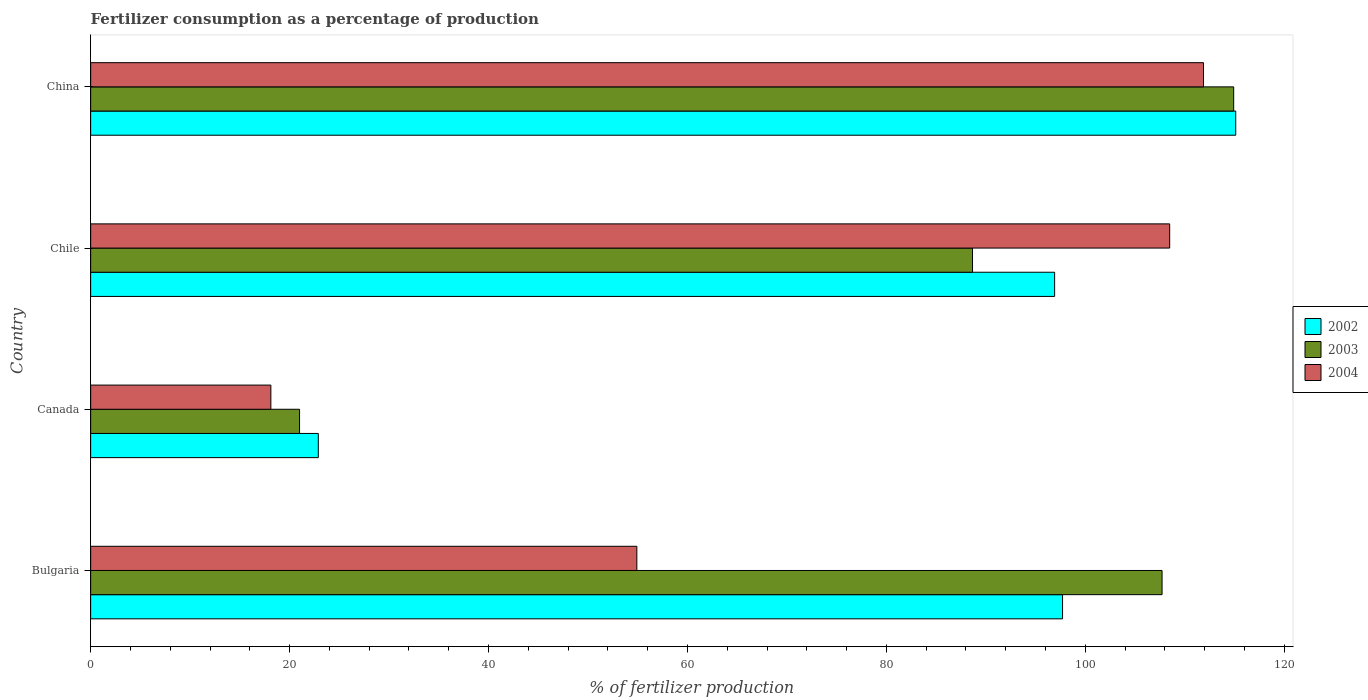How many different coloured bars are there?
Keep it short and to the point. 3. How many groups of bars are there?
Your answer should be compact. 4. Are the number of bars on each tick of the Y-axis equal?
Provide a succinct answer. Yes. How many bars are there on the 2nd tick from the top?
Keep it short and to the point. 3. How many bars are there on the 4th tick from the bottom?
Provide a short and direct response. 3. What is the percentage of fertilizers consumed in 2002 in Canada?
Keep it short and to the point. 22.89. Across all countries, what is the maximum percentage of fertilizers consumed in 2003?
Provide a short and direct response. 114.92. Across all countries, what is the minimum percentage of fertilizers consumed in 2003?
Offer a very short reply. 21. In which country was the percentage of fertilizers consumed in 2004 maximum?
Provide a succinct answer. China. What is the total percentage of fertilizers consumed in 2002 in the graph?
Give a very brief answer. 332.63. What is the difference between the percentage of fertilizers consumed in 2004 in Canada and that in China?
Make the answer very short. -93.77. What is the difference between the percentage of fertilizers consumed in 2003 in China and the percentage of fertilizers consumed in 2004 in Bulgaria?
Your answer should be very brief. 60. What is the average percentage of fertilizers consumed in 2003 per country?
Provide a succinct answer. 83.07. What is the difference between the percentage of fertilizers consumed in 2002 and percentage of fertilizers consumed in 2003 in Canada?
Make the answer very short. 1.88. In how many countries, is the percentage of fertilizers consumed in 2003 greater than 68 %?
Provide a short and direct response. 3. What is the ratio of the percentage of fertilizers consumed in 2002 in Bulgaria to that in Canada?
Provide a succinct answer. 4.27. Is the percentage of fertilizers consumed in 2002 in Canada less than that in China?
Give a very brief answer. Yes. Is the difference between the percentage of fertilizers consumed in 2002 in Bulgaria and Chile greater than the difference between the percentage of fertilizers consumed in 2003 in Bulgaria and Chile?
Make the answer very short. No. What is the difference between the highest and the second highest percentage of fertilizers consumed in 2003?
Your response must be concise. 7.2. What is the difference between the highest and the lowest percentage of fertilizers consumed in 2003?
Offer a terse response. 93.91. Is the sum of the percentage of fertilizers consumed in 2004 in Bulgaria and Canada greater than the maximum percentage of fertilizers consumed in 2003 across all countries?
Your answer should be very brief. No. Is it the case that in every country, the sum of the percentage of fertilizers consumed in 2003 and percentage of fertilizers consumed in 2002 is greater than the percentage of fertilizers consumed in 2004?
Provide a short and direct response. Yes. How many bars are there?
Offer a terse response. 12. How many countries are there in the graph?
Your answer should be very brief. 4. Are the values on the major ticks of X-axis written in scientific E-notation?
Offer a terse response. No. Does the graph contain any zero values?
Keep it short and to the point. No. Does the graph contain grids?
Your response must be concise. No. Where does the legend appear in the graph?
Keep it short and to the point. Center right. How many legend labels are there?
Offer a terse response. 3. What is the title of the graph?
Make the answer very short. Fertilizer consumption as a percentage of production. What is the label or title of the X-axis?
Keep it short and to the point. % of fertilizer production. What is the % of fertilizer production in 2002 in Bulgaria?
Keep it short and to the point. 97.71. What is the % of fertilizer production of 2003 in Bulgaria?
Provide a succinct answer. 107.72. What is the % of fertilizer production in 2004 in Bulgaria?
Your answer should be very brief. 54.91. What is the % of fertilizer production of 2002 in Canada?
Your answer should be compact. 22.89. What is the % of fertilizer production of 2003 in Canada?
Provide a succinct answer. 21. What is the % of fertilizer production in 2004 in Canada?
Your response must be concise. 18.12. What is the % of fertilizer production of 2002 in Chile?
Offer a terse response. 96.91. What is the % of fertilizer production of 2003 in Chile?
Keep it short and to the point. 88.66. What is the % of fertilizer production of 2004 in Chile?
Provide a short and direct response. 108.48. What is the % of fertilizer production in 2002 in China?
Your answer should be compact. 115.12. What is the % of fertilizer production of 2003 in China?
Offer a very short reply. 114.92. What is the % of fertilizer production in 2004 in China?
Your response must be concise. 111.88. Across all countries, what is the maximum % of fertilizer production in 2002?
Provide a succinct answer. 115.12. Across all countries, what is the maximum % of fertilizer production of 2003?
Your answer should be very brief. 114.92. Across all countries, what is the maximum % of fertilizer production of 2004?
Your answer should be compact. 111.88. Across all countries, what is the minimum % of fertilizer production in 2002?
Provide a short and direct response. 22.89. Across all countries, what is the minimum % of fertilizer production in 2003?
Ensure brevity in your answer.  21. Across all countries, what is the minimum % of fertilizer production of 2004?
Make the answer very short. 18.12. What is the total % of fertilizer production in 2002 in the graph?
Make the answer very short. 332.63. What is the total % of fertilizer production in 2003 in the graph?
Your response must be concise. 332.29. What is the total % of fertilizer production in 2004 in the graph?
Keep it short and to the point. 293.39. What is the difference between the % of fertilizer production of 2002 in Bulgaria and that in Canada?
Offer a very short reply. 74.82. What is the difference between the % of fertilizer production in 2003 in Bulgaria and that in Canada?
Offer a terse response. 86.71. What is the difference between the % of fertilizer production in 2004 in Bulgaria and that in Canada?
Provide a succinct answer. 36.8. What is the difference between the % of fertilizer production of 2002 in Bulgaria and that in Chile?
Provide a succinct answer. 0.8. What is the difference between the % of fertilizer production of 2003 in Bulgaria and that in Chile?
Offer a terse response. 19.06. What is the difference between the % of fertilizer production in 2004 in Bulgaria and that in Chile?
Your answer should be compact. -53.57. What is the difference between the % of fertilizer production of 2002 in Bulgaria and that in China?
Your answer should be very brief. -17.41. What is the difference between the % of fertilizer production in 2003 in Bulgaria and that in China?
Your response must be concise. -7.2. What is the difference between the % of fertilizer production in 2004 in Bulgaria and that in China?
Your answer should be very brief. -56.97. What is the difference between the % of fertilizer production in 2002 in Canada and that in Chile?
Your answer should be compact. -74.03. What is the difference between the % of fertilizer production of 2003 in Canada and that in Chile?
Offer a very short reply. -67.66. What is the difference between the % of fertilizer production of 2004 in Canada and that in Chile?
Your response must be concise. -90.37. What is the difference between the % of fertilizer production in 2002 in Canada and that in China?
Your answer should be compact. -92.24. What is the difference between the % of fertilizer production of 2003 in Canada and that in China?
Keep it short and to the point. -93.91. What is the difference between the % of fertilizer production in 2004 in Canada and that in China?
Give a very brief answer. -93.77. What is the difference between the % of fertilizer production of 2002 in Chile and that in China?
Offer a terse response. -18.21. What is the difference between the % of fertilizer production of 2003 in Chile and that in China?
Offer a terse response. -26.26. What is the difference between the % of fertilizer production in 2004 in Chile and that in China?
Your answer should be compact. -3.4. What is the difference between the % of fertilizer production of 2002 in Bulgaria and the % of fertilizer production of 2003 in Canada?
Offer a very short reply. 76.71. What is the difference between the % of fertilizer production of 2002 in Bulgaria and the % of fertilizer production of 2004 in Canada?
Keep it short and to the point. 79.59. What is the difference between the % of fertilizer production of 2003 in Bulgaria and the % of fertilizer production of 2004 in Canada?
Offer a very short reply. 89.6. What is the difference between the % of fertilizer production in 2002 in Bulgaria and the % of fertilizer production in 2003 in Chile?
Keep it short and to the point. 9.05. What is the difference between the % of fertilizer production of 2002 in Bulgaria and the % of fertilizer production of 2004 in Chile?
Give a very brief answer. -10.77. What is the difference between the % of fertilizer production of 2003 in Bulgaria and the % of fertilizer production of 2004 in Chile?
Ensure brevity in your answer.  -0.77. What is the difference between the % of fertilizer production of 2002 in Bulgaria and the % of fertilizer production of 2003 in China?
Give a very brief answer. -17.21. What is the difference between the % of fertilizer production in 2002 in Bulgaria and the % of fertilizer production in 2004 in China?
Give a very brief answer. -14.17. What is the difference between the % of fertilizer production in 2003 in Bulgaria and the % of fertilizer production in 2004 in China?
Ensure brevity in your answer.  -4.17. What is the difference between the % of fertilizer production of 2002 in Canada and the % of fertilizer production of 2003 in Chile?
Offer a terse response. -65.77. What is the difference between the % of fertilizer production in 2002 in Canada and the % of fertilizer production in 2004 in Chile?
Your answer should be very brief. -85.6. What is the difference between the % of fertilizer production in 2003 in Canada and the % of fertilizer production in 2004 in Chile?
Offer a very short reply. -87.48. What is the difference between the % of fertilizer production of 2002 in Canada and the % of fertilizer production of 2003 in China?
Keep it short and to the point. -92.03. What is the difference between the % of fertilizer production of 2002 in Canada and the % of fertilizer production of 2004 in China?
Your answer should be compact. -88.99. What is the difference between the % of fertilizer production in 2003 in Canada and the % of fertilizer production in 2004 in China?
Give a very brief answer. -90.88. What is the difference between the % of fertilizer production of 2002 in Chile and the % of fertilizer production of 2003 in China?
Your answer should be compact. -18. What is the difference between the % of fertilizer production in 2002 in Chile and the % of fertilizer production in 2004 in China?
Make the answer very short. -14.97. What is the difference between the % of fertilizer production in 2003 in Chile and the % of fertilizer production in 2004 in China?
Your answer should be very brief. -23.22. What is the average % of fertilizer production of 2002 per country?
Give a very brief answer. 83.16. What is the average % of fertilizer production in 2003 per country?
Make the answer very short. 83.07. What is the average % of fertilizer production of 2004 per country?
Provide a short and direct response. 73.35. What is the difference between the % of fertilizer production in 2002 and % of fertilizer production in 2003 in Bulgaria?
Give a very brief answer. -10.01. What is the difference between the % of fertilizer production of 2002 and % of fertilizer production of 2004 in Bulgaria?
Offer a terse response. 42.8. What is the difference between the % of fertilizer production in 2003 and % of fertilizer production in 2004 in Bulgaria?
Offer a very short reply. 52.8. What is the difference between the % of fertilizer production of 2002 and % of fertilizer production of 2003 in Canada?
Your answer should be compact. 1.88. What is the difference between the % of fertilizer production in 2002 and % of fertilizer production in 2004 in Canada?
Provide a short and direct response. 4.77. What is the difference between the % of fertilizer production in 2003 and % of fertilizer production in 2004 in Canada?
Offer a terse response. 2.89. What is the difference between the % of fertilizer production in 2002 and % of fertilizer production in 2003 in Chile?
Offer a terse response. 8.25. What is the difference between the % of fertilizer production of 2002 and % of fertilizer production of 2004 in Chile?
Keep it short and to the point. -11.57. What is the difference between the % of fertilizer production in 2003 and % of fertilizer production in 2004 in Chile?
Ensure brevity in your answer.  -19.82. What is the difference between the % of fertilizer production in 2002 and % of fertilizer production in 2003 in China?
Keep it short and to the point. 0.21. What is the difference between the % of fertilizer production in 2002 and % of fertilizer production in 2004 in China?
Your answer should be compact. 3.24. What is the difference between the % of fertilizer production of 2003 and % of fertilizer production of 2004 in China?
Your response must be concise. 3.03. What is the ratio of the % of fertilizer production in 2002 in Bulgaria to that in Canada?
Your response must be concise. 4.27. What is the ratio of the % of fertilizer production of 2003 in Bulgaria to that in Canada?
Provide a short and direct response. 5.13. What is the ratio of the % of fertilizer production of 2004 in Bulgaria to that in Canada?
Offer a very short reply. 3.03. What is the ratio of the % of fertilizer production in 2002 in Bulgaria to that in Chile?
Offer a very short reply. 1.01. What is the ratio of the % of fertilizer production in 2003 in Bulgaria to that in Chile?
Give a very brief answer. 1.21. What is the ratio of the % of fertilizer production of 2004 in Bulgaria to that in Chile?
Offer a terse response. 0.51. What is the ratio of the % of fertilizer production of 2002 in Bulgaria to that in China?
Your answer should be very brief. 0.85. What is the ratio of the % of fertilizer production of 2003 in Bulgaria to that in China?
Your answer should be very brief. 0.94. What is the ratio of the % of fertilizer production of 2004 in Bulgaria to that in China?
Your response must be concise. 0.49. What is the ratio of the % of fertilizer production of 2002 in Canada to that in Chile?
Give a very brief answer. 0.24. What is the ratio of the % of fertilizer production of 2003 in Canada to that in Chile?
Offer a terse response. 0.24. What is the ratio of the % of fertilizer production of 2004 in Canada to that in Chile?
Provide a succinct answer. 0.17. What is the ratio of the % of fertilizer production of 2002 in Canada to that in China?
Give a very brief answer. 0.2. What is the ratio of the % of fertilizer production in 2003 in Canada to that in China?
Offer a terse response. 0.18. What is the ratio of the % of fertilizer production of 2004 in Canada to that in China?
Make the answer very short. 0.16. What is the ratio of the % of fertilizer production of 2002 in Chile to that in China?
Your answer should be compact. 0.84. What is the ratio of the % of fertilizer production of 2003 in Chile to that in China?
Keep it short and to the point. 0.77. What is the ratio of the % of fertilizer production of 2004 in Chile to that in China?
Provide a short and direct response. 0.97. What is the difference between the highest and the second highest % of fertilizer production of 2002?
Your answer should be very brief. 17.41. What is the difference between the highest and the second highest % of fertilizer production of 2003?
Give a very brief answer. 7.2. What is the difference between the highest and the second highest % of fertilizer production in 2004?
Provide a succinct answer. 3.4. What is the difference between the highest and the lowest % of fertilizer production of 2002?
Your answer should be compact. 92.24. What is the difference between the highest and the lowest % of fertilizer production in 2003?
Your response must be concise. 93.91. What is the difference between the highest and the lowest % of fertilizer production in 2004?
Provide a short and direct response. 93.77. 